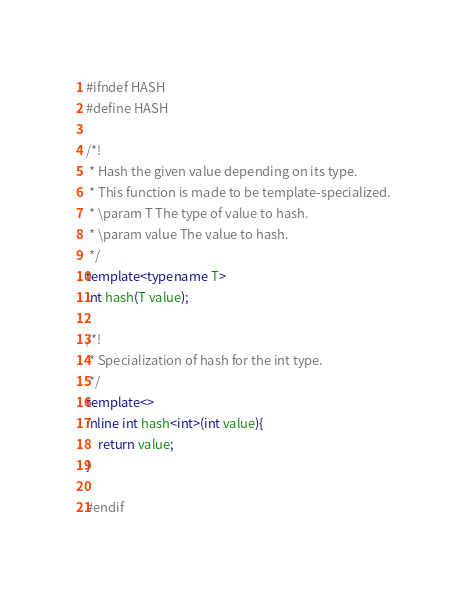Convert code to text. <code><loc_0><loc_0><loc_500><loc_500><_C++_>#ifndef HASH
#define HASH

/*!
 * Hash the given value depending on its type. 
 * This function is made to be template-specialized. 
 * \param T The type of value to hash. 
 * \param value The value to hash. 
 */
template<typename T>
int hash(T value);

/*!
 * Specialization of hash for the int type. 
 */
template<>
inline int hash<int>(int value){
    return value;
}

#endif
</code> 